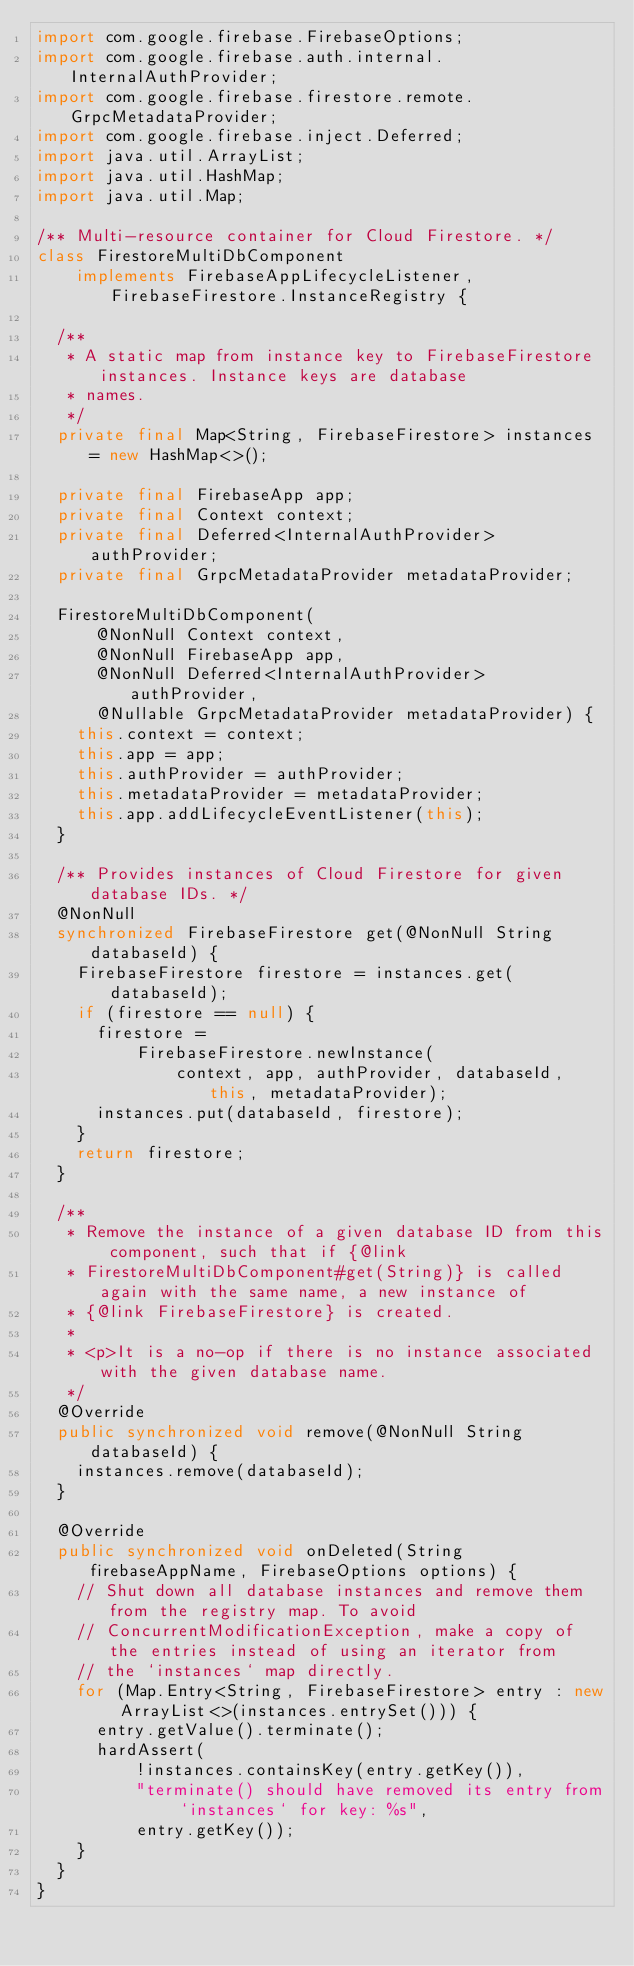Convert code to text. <code><loc_0><loc_0><loc_500><loc_500><_Java_>import com.google.firebase.FirebaseOptions;
import com.google.firebase.auth.internal.InternalAuthProvider;
import com.google.firebase.firestore.remote.GrpcMetadataProvider;
import com.google.firebase.inject.Deferred;
import java.util.ArrayList;
import java.util.HashMap;
import java.util.Map;

/** Multi-resource container for Cloud Firestore. */
class FirestoreMultiDbComponent
    implements FirebaseAppLifecycleListener, FirebaseFirestore.InstanceRegistry {

  /**
   * A static map from instance key to FirebaseFirestore instances. Instance keys are database
   * names.
   */
  private final Map<String, FirebaseFirestore> instances = new HashMap<>();

  private final FirebaseApp app;
  private final Context context;
  private final Deferred<InternalAuthProvider> authProvider;
  private final GrpcMetadataProvider metadataProvider;

  FirestoreMultiDbComponent(
      @NonNull Context context,
      @NonNull FirebaseApp app,
      @NonNull Deferred<InternalAuthProvider> authProvider,
      @Nullable GrpcMetadataProvider metadataProvider) {
    this.context = context;
    this.app = app;
    this.authProvider = authProvider;
    this.metadataProvider = metadataProvider;
    this.app.addLifecycleEventListener(this);
  }

  /** Provides instances of Cloud Firestore for given database IDs. */
  @NonNull
  synchronized FirebaseFirestore get(@NonNull String databaseId) {
    FirebaseFirestore firestore = instances.get(databaseId);
    if (firestore == null) {
      firestore =
          FirebaseFirestore.newInstance(
              context, app, authProvider, databaseId, this, metadataProvider);
      instances.put(databaseId, firestore);
    }
    return firestore;
  }

  /**
   * Remove the instance of a given database ID from this component, such that if {@link
   * FirestoreMultiDbComponent#get(String)} is called again with the same name, a new instance of
   * {@link FirebaseFirestore} is created.
   *
   * <p>It is a no-op if there is no instance associated with the given database name.
   */
  @Override
  public synchronized void remove(@NonNull String databaseId) {
    instances.remove(databaseId);
  }

  @Override
  public synchronized void onDeleted(String firebaseAppName, FirebaseOptions options) {
    // Shut down all database instances and remove them from the registry map. To avoid
    // ConcurrentModificationException, make a copy of the entries instead of using an iterator from
    // the `instances` map directly.
    for (Map.Entry<String, FirebaseFirestore> entry : new ArrayList<>(instances.entrySet())) {
      entry.getValue().terminate();
      hardAssert(
          !instances.containsKey(entry.getKey()),
          "terminate() should have removed its entry from `instances` for key: %s",
          entry.getKey());
    }
  }
}
</code> 